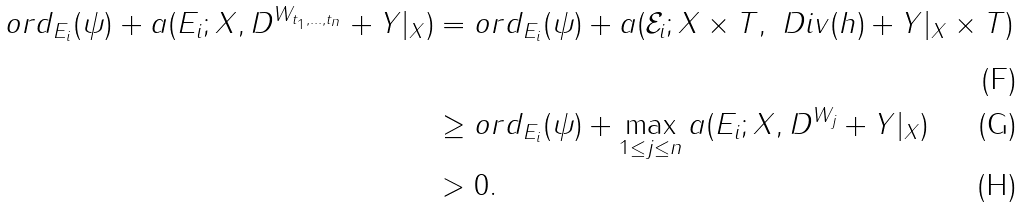<formula> <loc_0><loc_0><loc_500><loc_500>o r d _ { E _ { i } } ( \psi ) + a ( E _ { i } ; X , D ^ { W _ { t _ { 1 } , \dots , t _ { n } } } + Y | _ { X } ) & = o r d _ { E _ { i } } ( \psi ) + a ( \mathcal { E } _ { i } ; X \times T , \ D i v ( h ) + Y | _ { X } \times T ) \\ & \geq o r d _ { E _ { i } } ( \psi ) + \max _ { 1 \leq j \leq n } a ( E _ { i } ; X , D ^ { W _ { j } } + Y | _ { X } ) \\ & > 0 .</formula> 